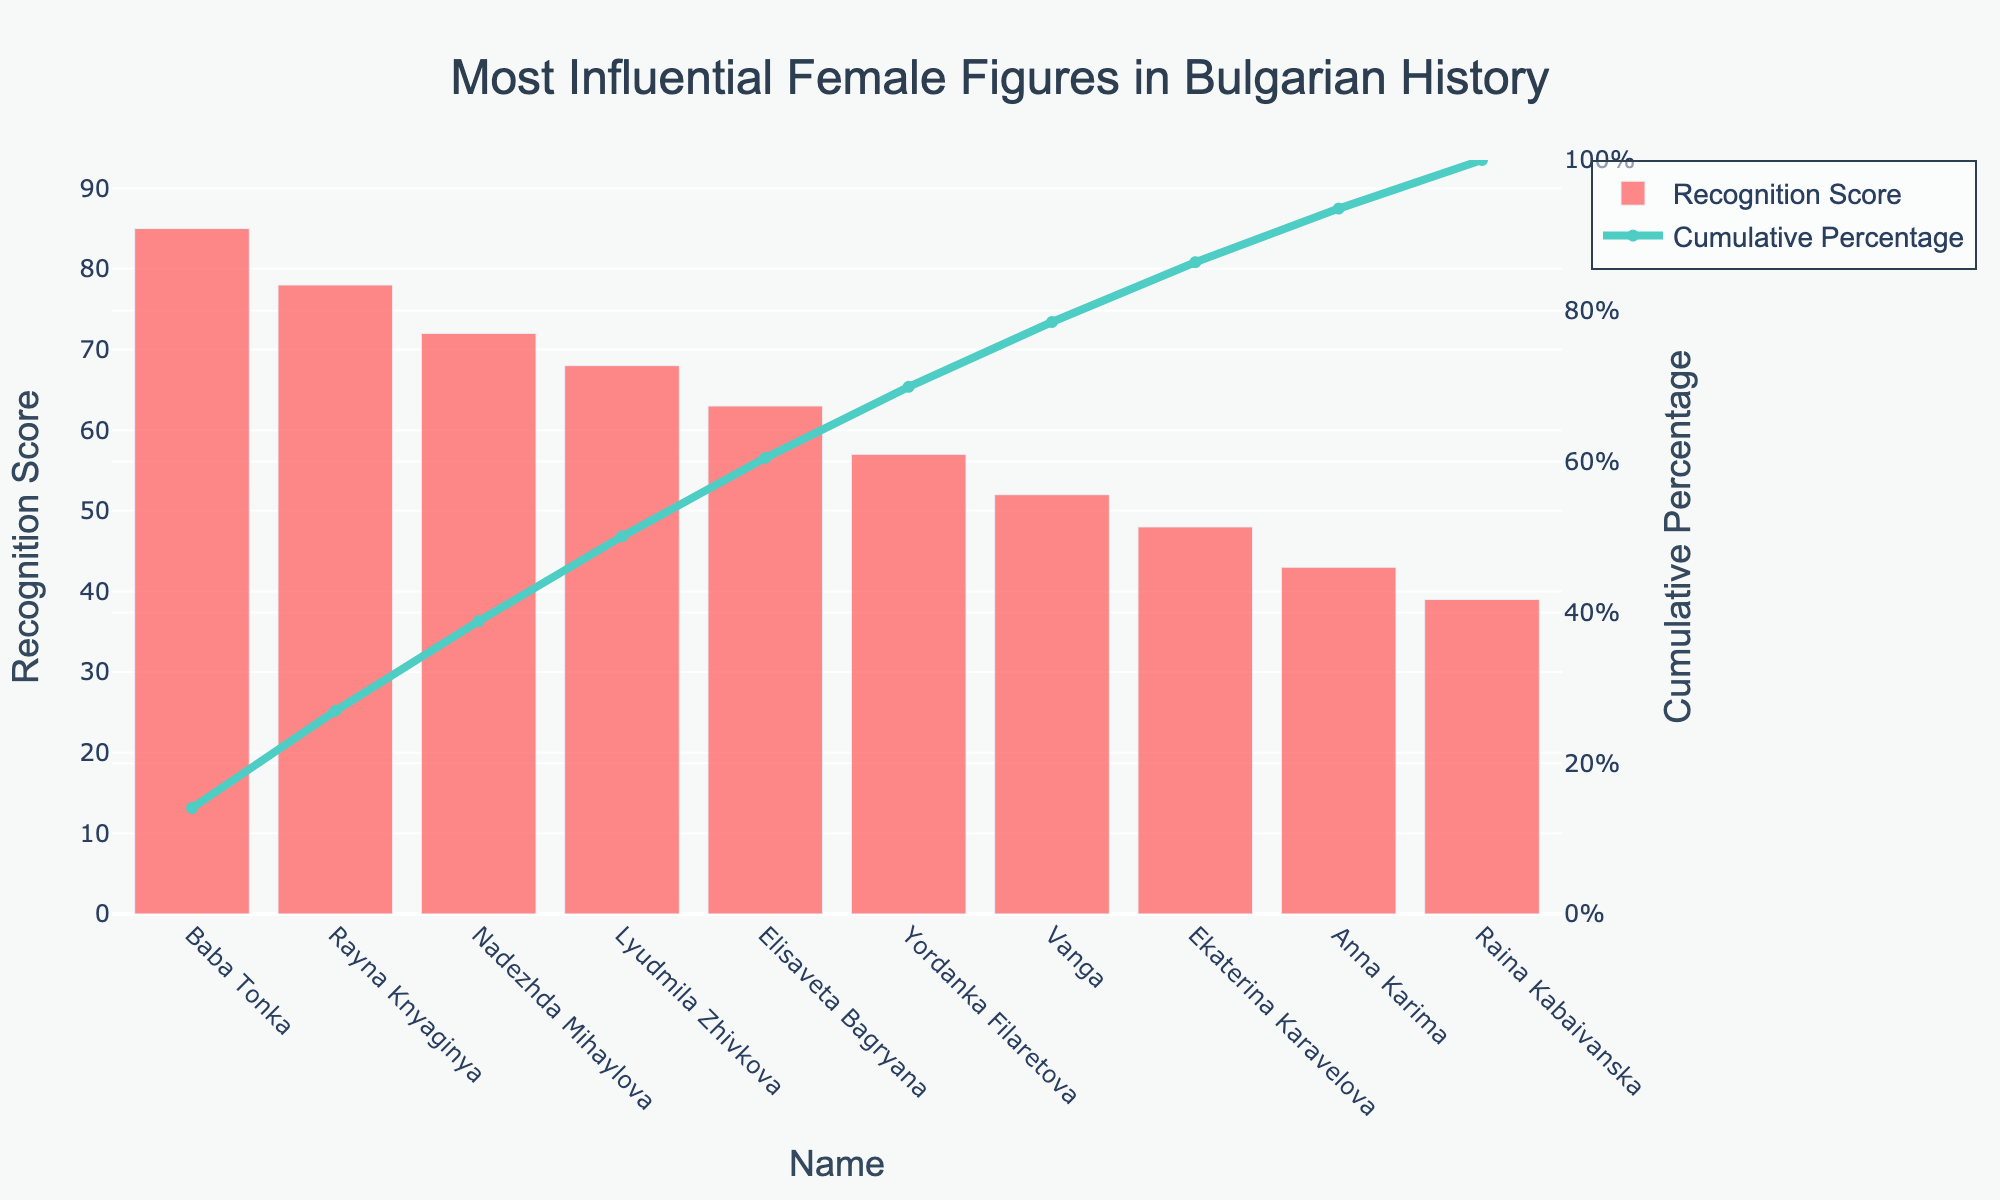What is the Recognition Score of Rayna Knyaginya? Look at the bar corresponding to Rayna Knyaginya on the x-axis; the height of the bar shows the Recognition Score.
Answer: 78 What is the title of the chart? The title is displayed at the top of the chart.
Answer: Most Influential Female Figures in Bulgarian History What is the Cumulative Percentage for Anna Karima? Find Anna Karima on the x-axis and check the corresponding point on the Cumulative Percentage line.
Answer: 85.1% Who has the highest Recognition Score? The tallest bar represents the highest Recognition Score. Identify the name on the x-axis below this bar.
Answer: Baba Tonka What is the range of the y-axis for the Recognition Score? The y-axis on the left shows the range of values for the Recognition Score.
Answer: 0 to 93.5 Where does the Cumulative Percentage line start and end? The Cumulative Percentage line starts at 0% and ends at 100%, as shown by its endpoints on the y-axis on the right.
Answer: 0% to 100% Who has the lowest Recognition Score, and what is the value? The shortest bar represents the lowest Recognition Score. Identify the name on the x-axis below this bar and read the value.
Answer: Raina Kabaivanska, 39 How many individuals have Recognition Scores above 60? Count the number of bars with heights above the y-axis value of 60.
Answer: 5 What is the combined Recognition Score of Baba Tonka and Rayna Knyaginya? Add the Recognition Scores of Baba Tonka and Rayna Knyaginya (85 + 78).
Answer: 163 Which individual crosses the 50% mark of Cumulative Percentage first? Find the point where the Cumulative Percentage line crosses 50% on the y-axis and note the corresponding name on the x-axis.
Answer: Rayna Knyaginya 